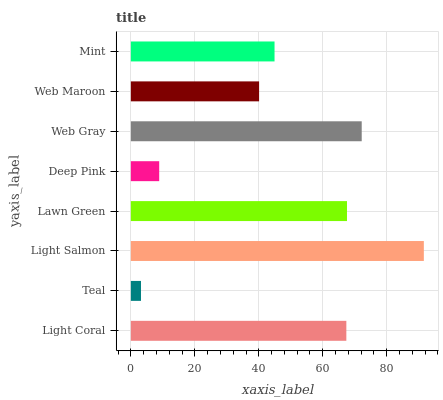Is Teal the minimum?
Answer yes or no. Yes. Is Light Salmon the maximum?
Answer yes or no. Yes. Is Light Salmon the minimum?
Answer yes or no. No. Is Teal the maximum?
Answer yes or no. No. Is Light Salmon greater than Teal?
Answer yes or no. Yes. Is Teal less than Light Salmon?
Answer yes or no. Yes. Is Teal greater than Light Salmon?
Answer yes or no. No. Is Light Salmon less than Teal?
Answer yes or no. No. Is Light Coral the high median?
Answer yes or no. Yes. Is Mint the low median?
Answer yes or no. Yes. Is Deep Pink the high median?
Answer yes or no. No. Is Lawn Green the low median?
Answer yes or no. No. 